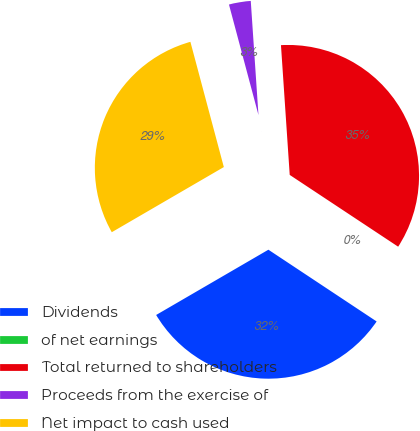<chart> <loc_0><loc_0><loc_500><loc_500><pie_chart><fcel>Dividends<fcel>of net earnings<fcel>Total returned to shareholders<fcel>Proceeds from the exercise of<fcel>Net impact to cash used<nl><fcel>32.3%<fcel>0.01%<fcel>35.38%<fcel>3.08%<fcel>29.23%<nl></chart> 